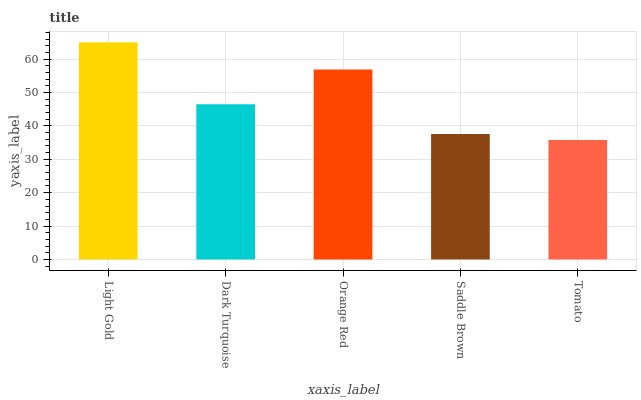Is Tomato the minimum?
Answer yes or no. Yes. Is Light Gold the maximum?
Answer yes or no. Yes. Is Dark Turquoise the minimum?
Answer yes or no. No. Is Dark Turquoise the maximum?
Answer yes or no. No. Is Light Gold greater than Dark Turquoise?
Answer yes or no. Yes. Is Dark Turquoise less than Light Gold?
Answer yes or no. Yes. Is Dark Turquoise greater than Light Gold?
Answer yes or no. No. Is Light Gold less than Dark Turquoise?
Answer yes or no. No. Is Dark Turquoise the high median?
Answer yes or no. Yes. Is Dark Turquoise the low median?
Answer yes or no. Yes. Is Light Gold the high median?
Answer yes or no. No. Is Saddle Brown the low median?
Answer yes or no. No. 